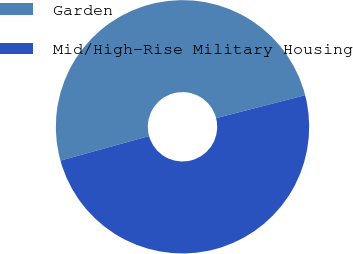Convert chart to OTSL. <chart><loc_0><loc_0><loc_500><loc_500><pie_chart><fcel>Garden<fcel>Mid/High-Rise Military Housing<nl><fcel>50.29%<fcel>49.71%<nl></chart> 